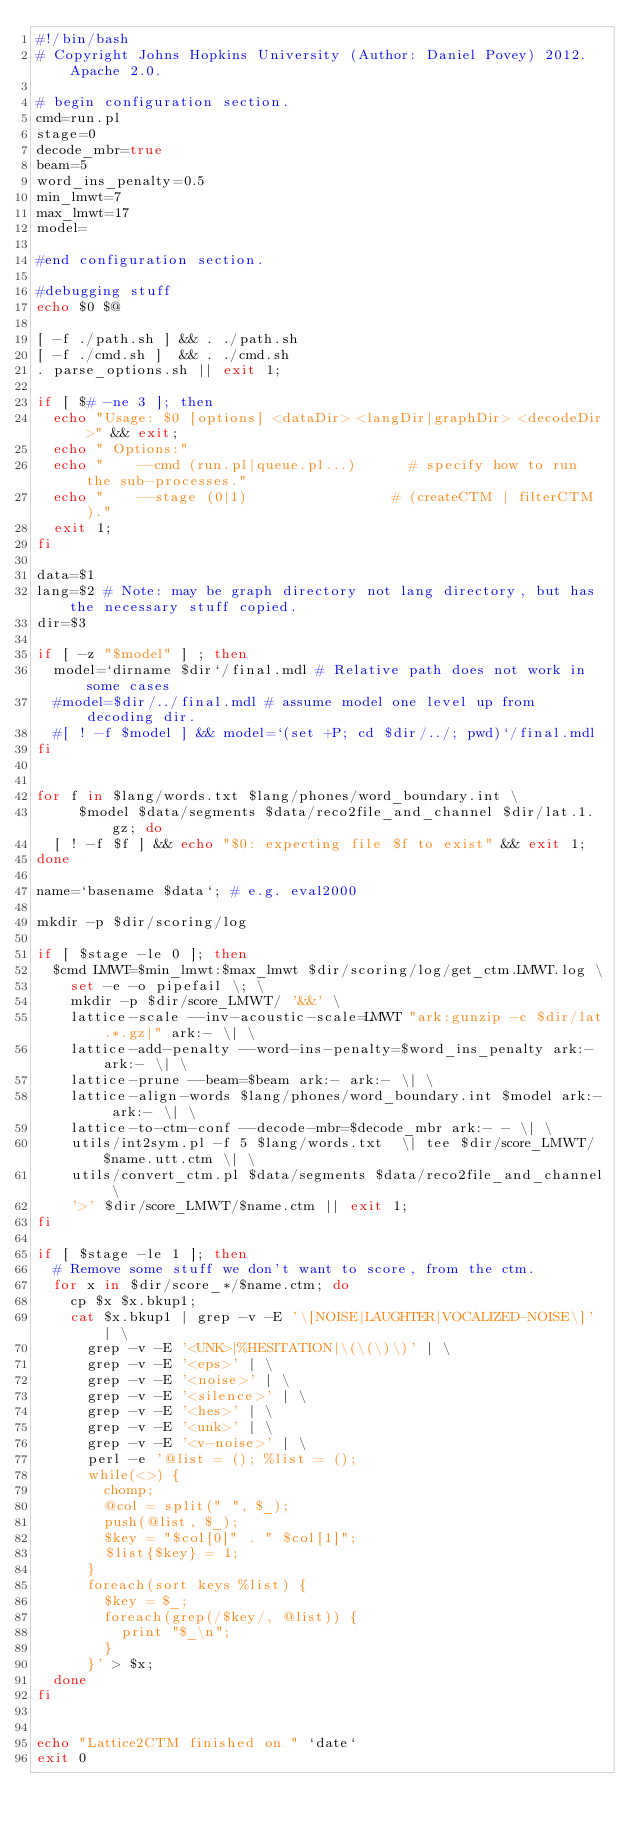<code> <loc_0><loc_0><loc_500><loc_500><_Bash_>#!/bin/bash
# Copyright Johns Hopkins University (Author: Daniel Povey) 2012.  Apache 2.0.

# begin configuration section.
cmd=run.pl
stage=0
decode_mbr=true
beam=5
word_ins_penalty=0.5
min_lmwt=7
max_lmwt=17
model=

#end configuration section.

#debugging stuff
echo $0 $@

[ -f ./path.sh ] && . ./path.sh
[ -f ./cmd.sh ]  && . ./cmd.sh
. parse_options.sh || exit 1;

if [ $# -ne 3 ]; then
  echo "Usage: $0 [options] <dataDir> <langDir|graphDir> <decodeDir>" && exit;
  echo " Options:"
  echo "    --cmd (run.pl|queue.pl...)      # specify how to run the sub-processes."
  echo "    --stage (0|1)                 # (createCTM | filterCTM )."
  exit 1;
fi

data=$1
lang=$2 # Note: may be graph directory not lang directory, but has the necessary stuff copied.
dir=$3

if [ -z "$model" ] ; then
  model=`dirname $dir`/final.mdl # Relative path does not work in some cases
  #model=$dir/../final.mdl # assume model one level up from decoding dir.
  #[ ! -f $model ] && model=`(set +P; cd $dir/../; pwd)`/final.mdl
fi


for f in $lang/words.txt $lang/phones/word_boundary.int \
     $model $data/segments $data/reco2file_and_channel $dir/lat.1.gz; do
  [ ! -f $f ] && echo "$0: expecting file $f to exist" && exit 1;
done

name=`basename $data`; # e.g. eval2000

mkdir -p $dir/scoring/log

if [ $stage -le 0 ]; then
  $cmd LMWT=$min_lmwt:$max_lmwt $dir/scoring/log/get_ctm.LMWT.log \
    set -e -o pipefail \; \
    mkdir -p $dir/score_LMWT/ '&&' \
    lattice-scale --inv-acoustic-scale=LMWT "ark:gunzip -c $dir/lat.*.gz|" ark:- \| \
    lattice-add-penalty --word-ins-penalty=$word_ins_penalty ark:- ark:- \| \
    lattice-prune --beam=$beam ark:- ark:- \| \
    lattice-align-words $lang/phones/word_boundary.int $model ark:- ark:- \| \
    lattice-to-ctm-conf --decode-mbr=$decode_mbr ark:- - \| \
    utils/int2sym.pl -f 5 $lang/words.txt  \| tee $dir/score_LMWT/$name.utt.ctm \| \
    utils/convert_ctm.pl $data/segments $data/reco2file_and_channel \
    '>' $dir/score_LMWT/$name.ctm || exit 1;
fi

if [ $stage -le 1 ]; then
  # Remove some stuff we don't want to score, from the ctm.
  for x in $dir/score_*/$name.ctm; do
    cp $x $x.bkup1;
    cat $x.bkup1 | grep -v -E '\[NOISE|LAUGHTER|VOCALIZED-NOISE\]' | \
      grep -v -E '<UNK>|%HESITATION|\(\(\)\)' | \
      grep -v -E '<eps>' | \
      grep -v -E '<noise>' | \
      grep -v -E '<silence>' | \
      grep -v -E '<hes>' | \
      grep -v -E '<unk>' | \
      grep -v -E '<v-noise>' | \
      perl -e '@list = (); %list = ();
      while(<>) {
        chomp; 
        @col = split(" ", $_); 
        push(@list, $_);
        $key = "$col[0]" . " $col[1]"; 
        $list{$key} = 1;
      } 
      foreach(sort keys %list) {
        $key = $_;
        foreach(grep(/$key/, @list)) {
          print "$_\n";
        }
      }' > $x;
  done
fi


echo "Lattice2CTM finished on " `date`
exit 0
</code> 